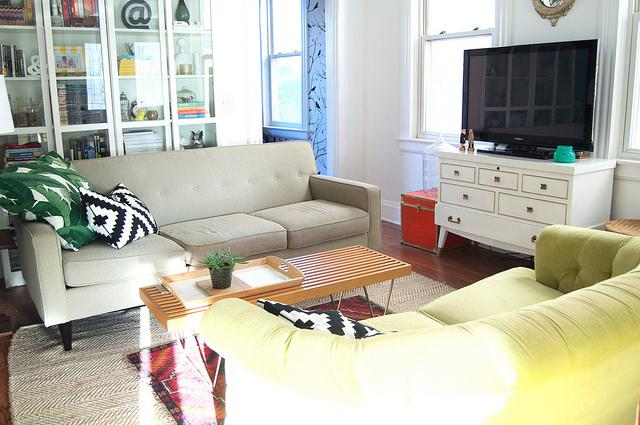What color is the vase on the right side of the white entertainment center? Please explain your reasoning. turquoise. The color is turquoise. 